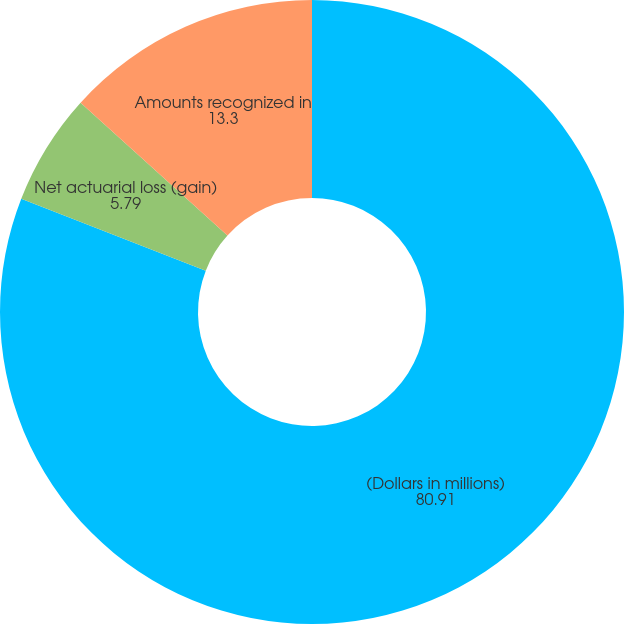Convert chart. <chart><loc_0><loc_0><loc_500><loc_500><pie_chart><fcel>(Dollars in millions)<fcel>Net actuarial loss (gain)<fcel>Amounts recognized in<nl><fcel>80.91%<fcel>5.79%<fcel>13.3%<nl></chart> 